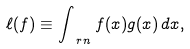Convert formula to latex. <formula><loc_0><loc_0><loc_500><loc_500>\ell ( f ) \equiv \int _ { \ r n } f ( x ) g ( x ) \, d x ,</formula> 